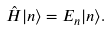<formula> <loc_0><loc_0><loc_500><loc_500>\hat { H } | n \rangle = E _ { n } | n \rangle .</formula> 